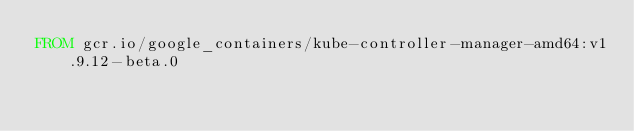Convert code to text. <code><loc_0><loc_0><loc_500><loc_500><_Dockerfile_>FROM gcr.io/google_containers/kube-controller-manager-amd64:v1.9.12-beta.0
</code> 